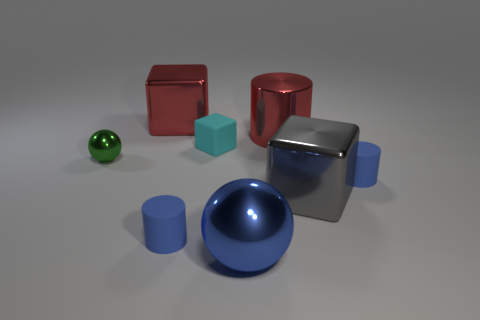Add 1 red metallic things. How many objects exist? 9 Subtract all spheres. How many objects are left? 6 Add 3 cubes. How many cubes exist? 6 Subtract 0 cyan spheres. How many objects are left? 8 Subtract all small green shiny balls. Subtract all tiny blue matte things. How many objects are left? 5 Add 1 small blue things. How many small blue things are left? 3 